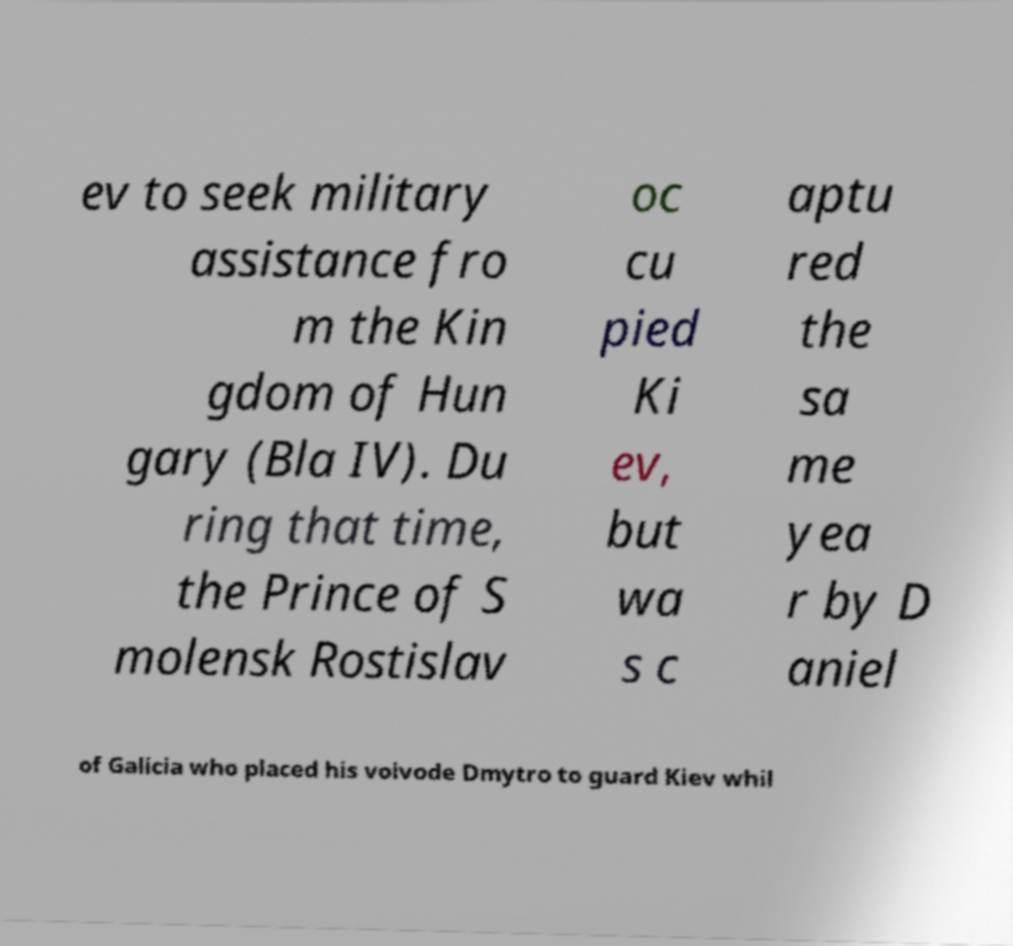Please identify and transcribe the text found in this image. ev to seek military assistance fro m the Kin gdom of Hun gary (Bla IV). Du ring that time, the Prince of S molensk Rostislav oc cu pied Ki ev, but wa s c aptu red the sa me yea r by D aniel of Galicia who placed his voivode Dmytro to guard Kiev whil 